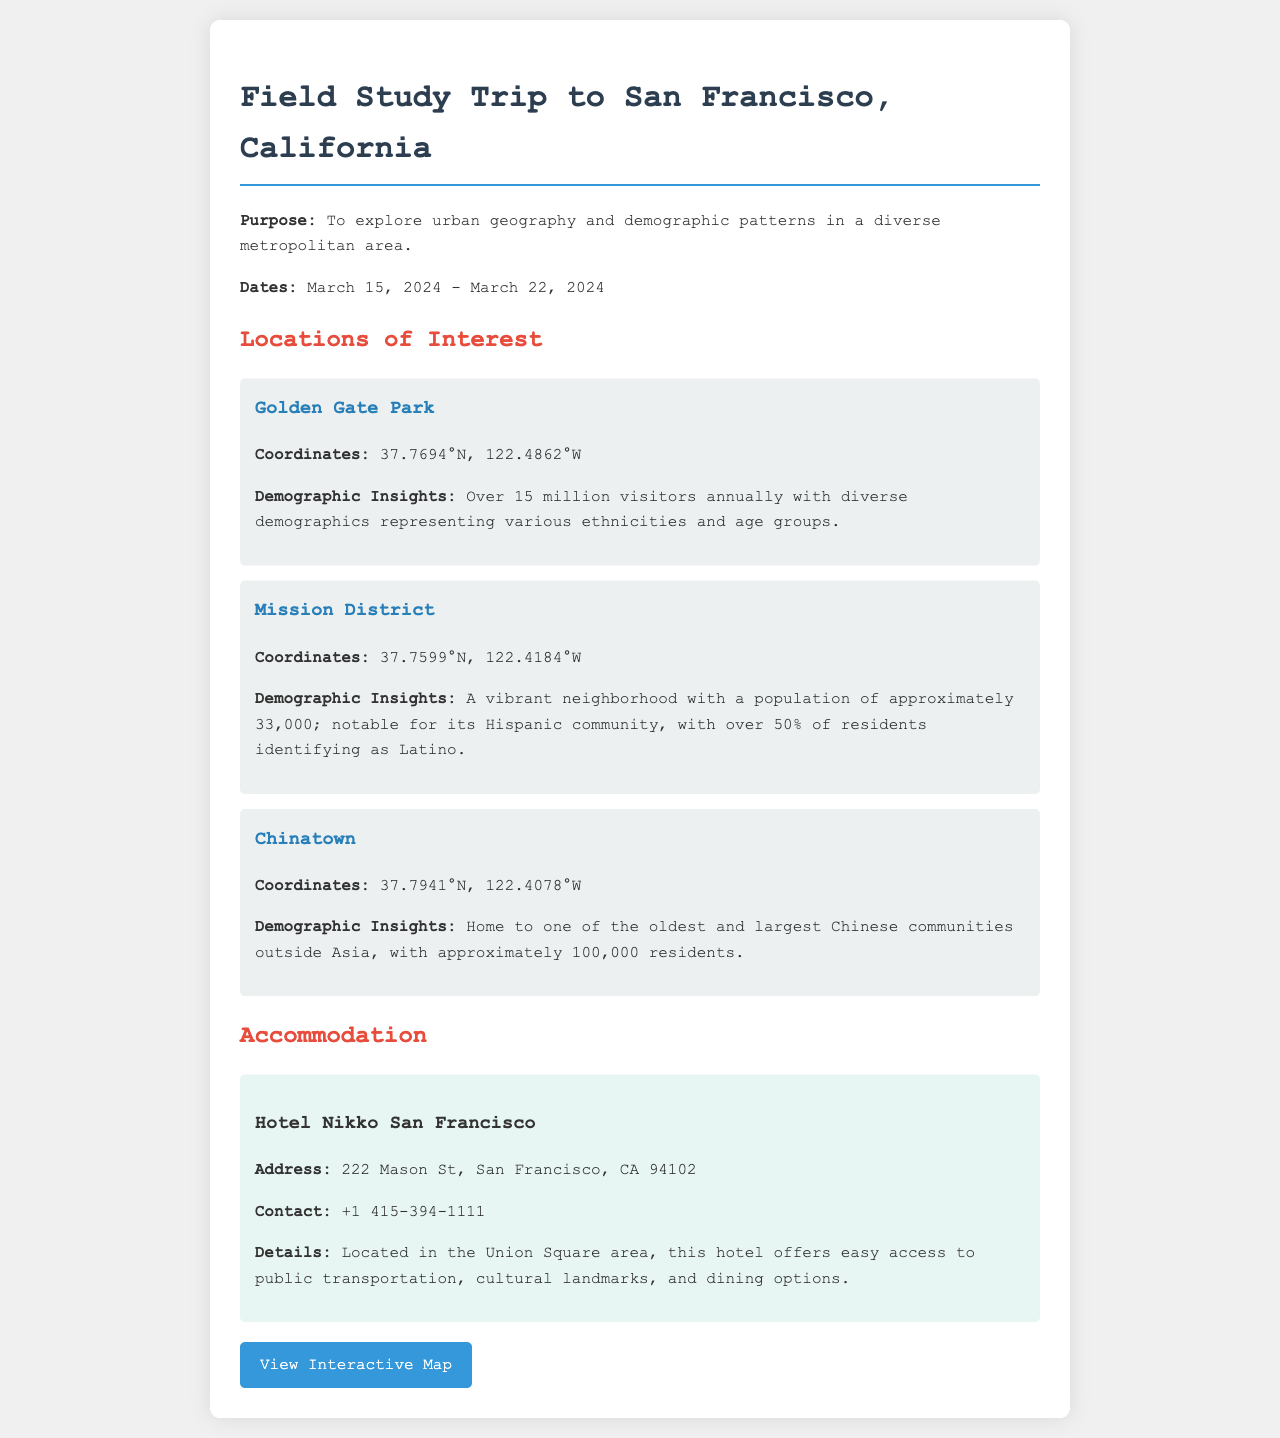what are the dates of the trip? The document states that the trip will take place from March 15, 2024 to March 22, 2024.
Answer: March 15, 2024 - March 22, 2024 how many visitors does Golden Gate Park attract annually? The document mentions that Golden Gate Park attracts over 15 million visitors annually.
Answer: over 15 million what is the population of the Mission District? The document indicates that the Mission District has a population of approximately 33,000.
Answer: approximately 33,000 what is the address of Hotel Nikko San Francisco? The document provides the address as 222 Mason St, San Francisco, CA 94102.
Answer: 222 Mason St, San Francisco, CA 94102 what percentage of Mission District residents identify as Latino? The document notes that over 50% of Mission District residents identify as Latino.
Answer: over 50% how many residents are there in Chinatown? The document states that Chinatown has approximately 100,000 residents.
Answer: approximately 100,000 why is Hotel Nikko located in a strategic area? The document explains Hotel Nikko's strategic location as providing easy access to public transportation, cultural landmarks, and dining options.
Answer: easy access to public transportation, cultural landmarks, and dining options what type of study is this field trip focused on? The document mentions that the purpose is to explore urban geography and demographic patterns.
Answer: urban geography and demographic patterns what map can participants view for directions? The document provides a link to an interactive map for participants to view.
Answer: View Interactive Map 